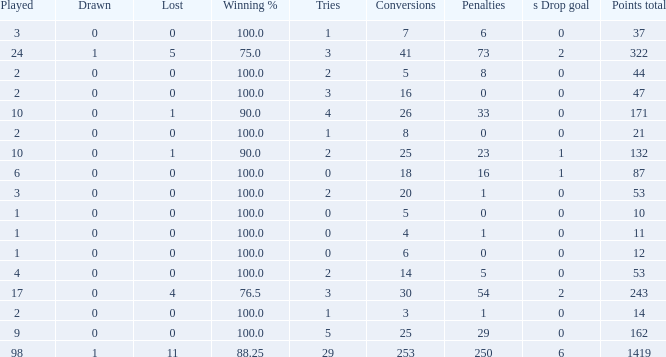With 1 penalty and more than 20 conversions, what was the number of ties he had? None. 